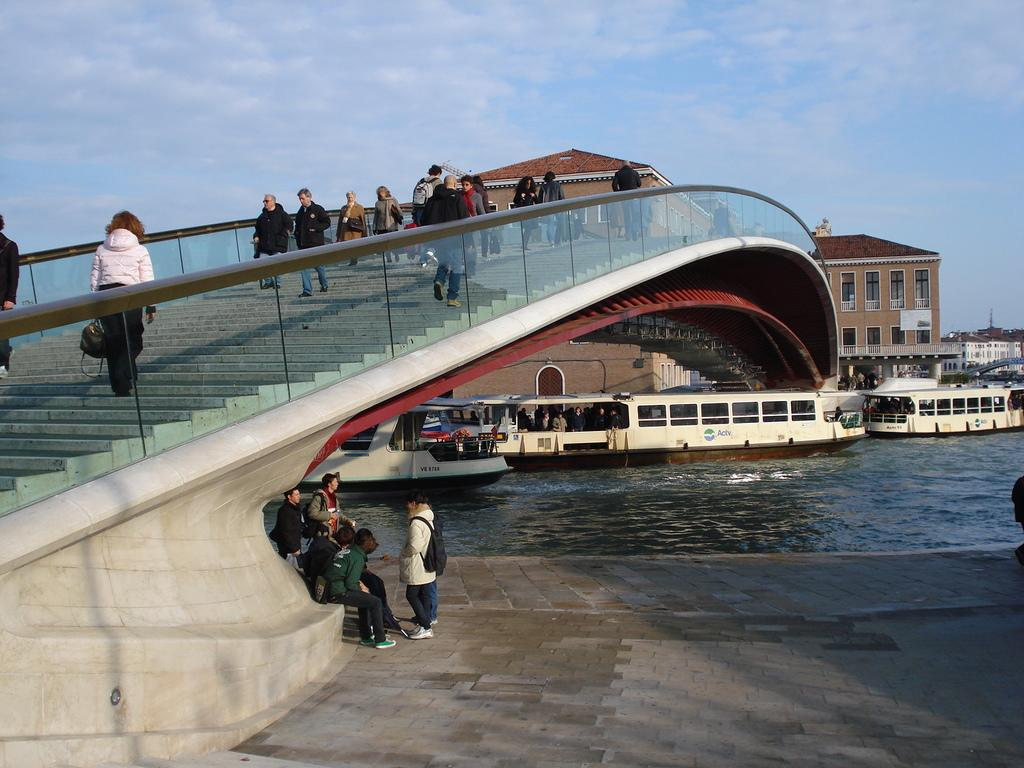What are the people doing in the foreground of the image? There are people on the stairs in the foreground. Where are the other people located in the image? There are people at the bottom side. What can be seen on the surface of the water in the image? There are ships on the surface of the water. What type of structures can be seen in the background of the image? There are houses in the background. What is visible in the sky in the image? The sky is visible in the background. Can you see a plant smiling in the image? There is no plant present in the image, and plants do not have the ability to smile. 